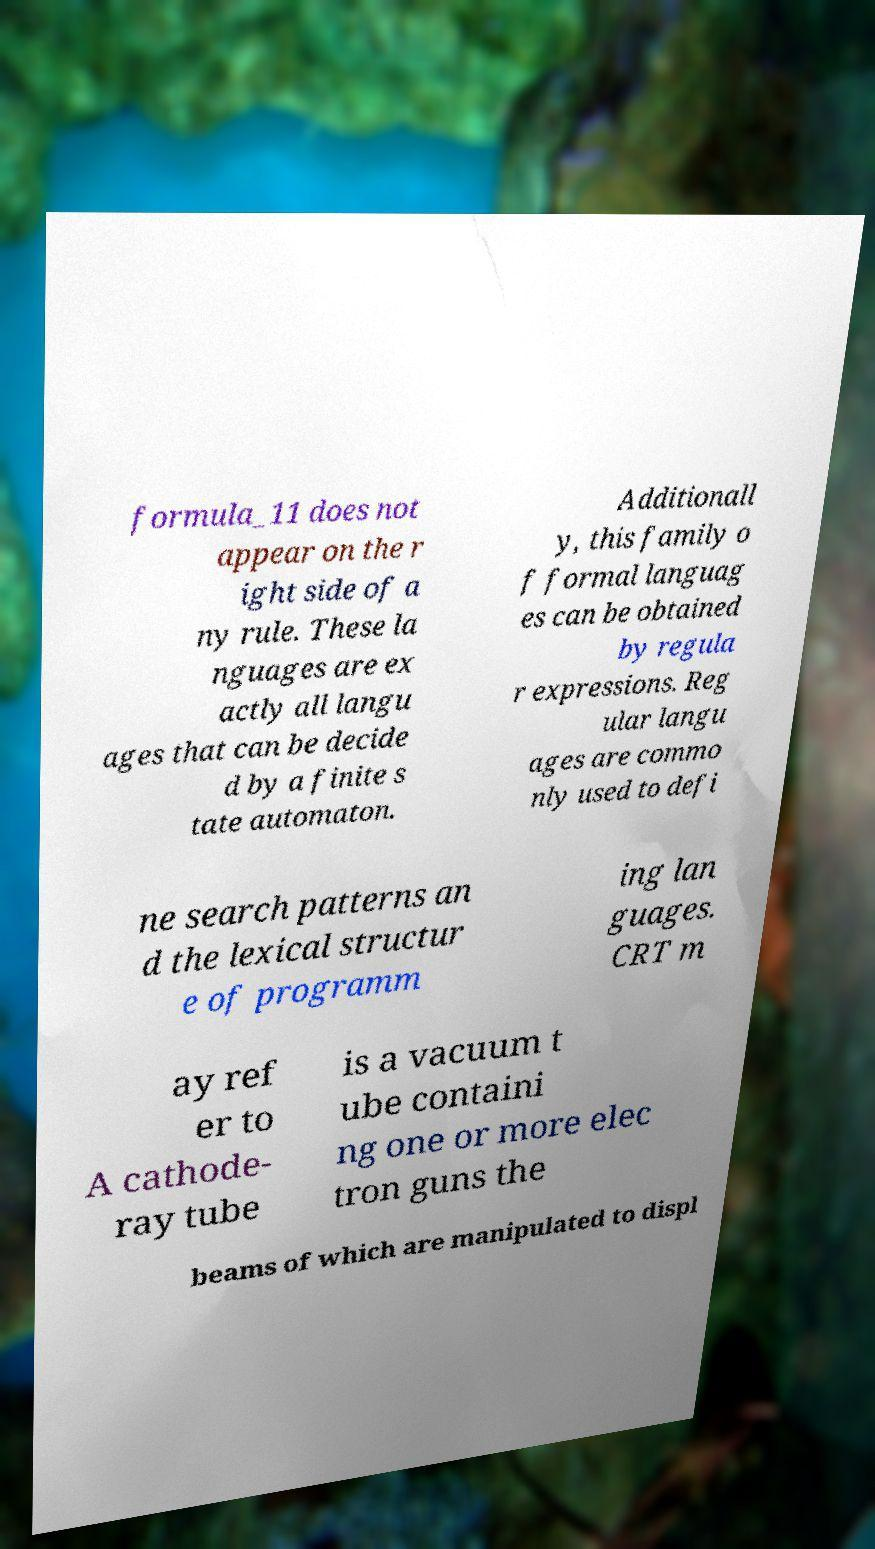Can you read and provide the text displayed in the image?This photo seems to have some interesting text. Can you extract and type it out for me? formula_11 does not appear on the r ight side of a ny rule. These la nguages are ex actly all langu ages that can be decide d by a finite s tate automaton. Additionall y, this family o f formal languag es can be obtained by regula r expressions. Reg ular langu ages are commo nly used to defi ne search patterns an d the lexical structur e of programm ing lan guages. CRT m ay ref er to A cathode- ray tube is a vacuum t ube containi ng one or more elec tron guns the beams of which are manipulated to displ 